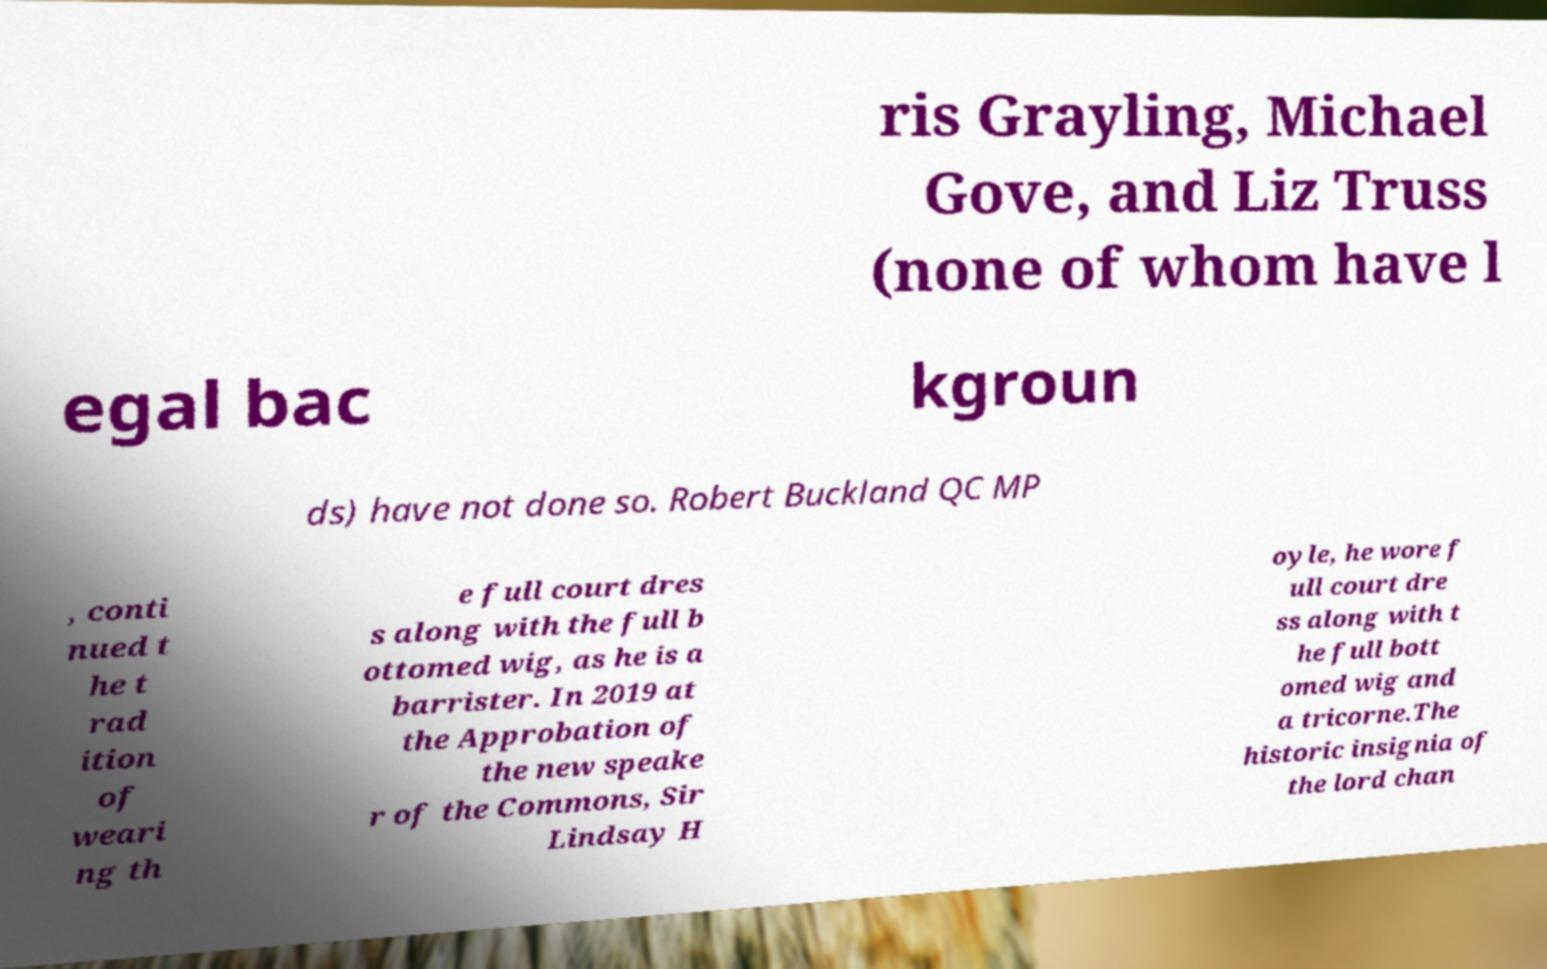For documentation purposes, I need the text within this image transcribed. Could you provide that? ris Grayling, Michael Gove, and Liz Truss (none of whom have l egal bac kgroun ds) have not done so. Robert Buckland QC MP , conti nued t he t rad ition of weari ng th e full court dres s along with the full b ottomed wig, as he is a barrister. In 2019 at the Approbation of the new speake r of the Commons, Sir Lindsay H oyle, he wore f ull court dre ss along with t he full bott omed wig and a tricorne.The historic insignia of the lord chan 